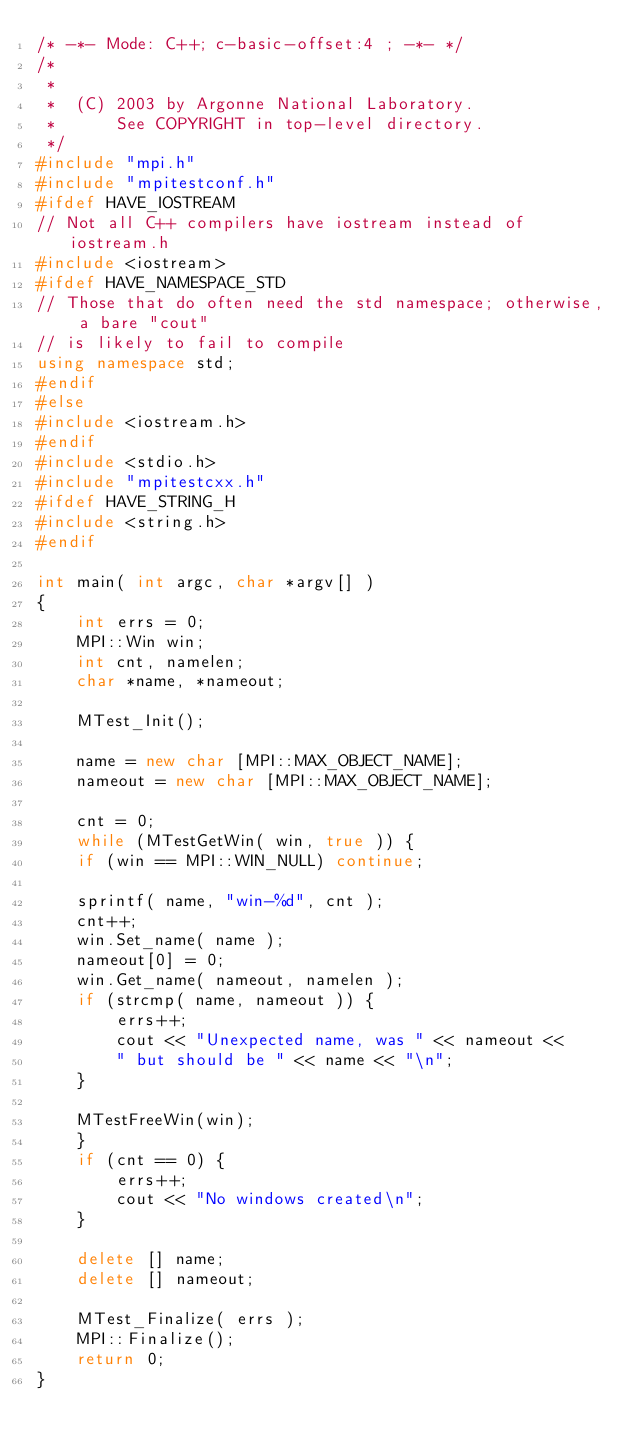<code> <loc_0><loc_0><loc_500><loc_500><_C++_>/* -*- Mode: C++; c-basic-offset:4 ; -*- */
/*
 *
 *  (C) 2003 by Argonne National Laboratory.
 *      See COPYRIGHT in top-level directory.
 */
#include "mpi.h"
#include "mpitestconf.h"
#ifdef HAVE_IOSTREAM
// Not all C++ compilers have iostream instead of iostream.h
#include <iostream>
#ifdef HAVE_NAMESPACE_STD
// Those that do often need the std namespace; otherwise, a bare "cout"
// is likely to fail to compile
using namespace std;
#endif
#else
#include <iostream.h>
#endif
#include <stdio.h>
#include "mpitestcxx.h"
#ifdef HAVE_STRING_H
#include <string.h>
#endif

int main( int argc, char *argv[] )
{
    int errs = 0;
    MPI::Win win;
    int cnt, namelen;
    char *name, *nameout;

    MTest_Init();

    name = new char [MPI::MAX_OBJECT_NAME];
    nameout = new char [MPI::MAX_OBJECT_NAME];

    cnt = 0;
    while (MTestGetWin( win, true )) {
	if (win == MPI::WIN_NULL) continue;
    
	sprintf( name, "win-%d", cnt );
	cnt++;
	win.Set_name( name );
	nameout[0] = 0;
	win.Get_name( nameout, namelen );
	if (strcmp( name, nameout )) {
	    errs++;
	    cout << "Unexpected name, was " << nameout << 
		" but should be " << name << "\n";
	}

	MTestFreeWin(win);
    }
    if (cnt == 0) {
        errs++;
        cout << "No windows created\n";
    }

    delete [] name;
    delete [] nameout;

    MTest_Finalize( errs );
    MPI::Finalize();
    return 0;
}
</code> 